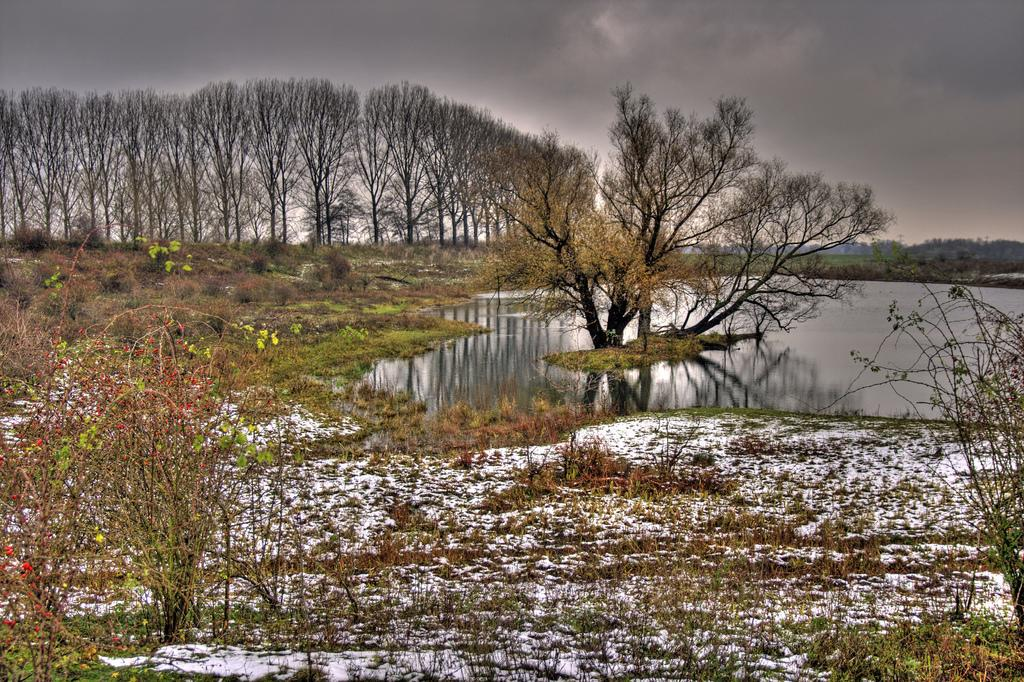What type of vegetation is present in the image? There are trees in the image. What is covering the ground in the image? There is grass on the ground in the image. What natural element is visible in the image? There is water visible in the image. What is the condition of the sky in the image? The sky in the image is cloudy. What type of cheese can be seen melting on the chin of the person in the image? There is no person or cheese present in the image. What type of liquid is visible dripping from the chin of the person in the image? There is no person or liquid dripping from a chin present in the image. 